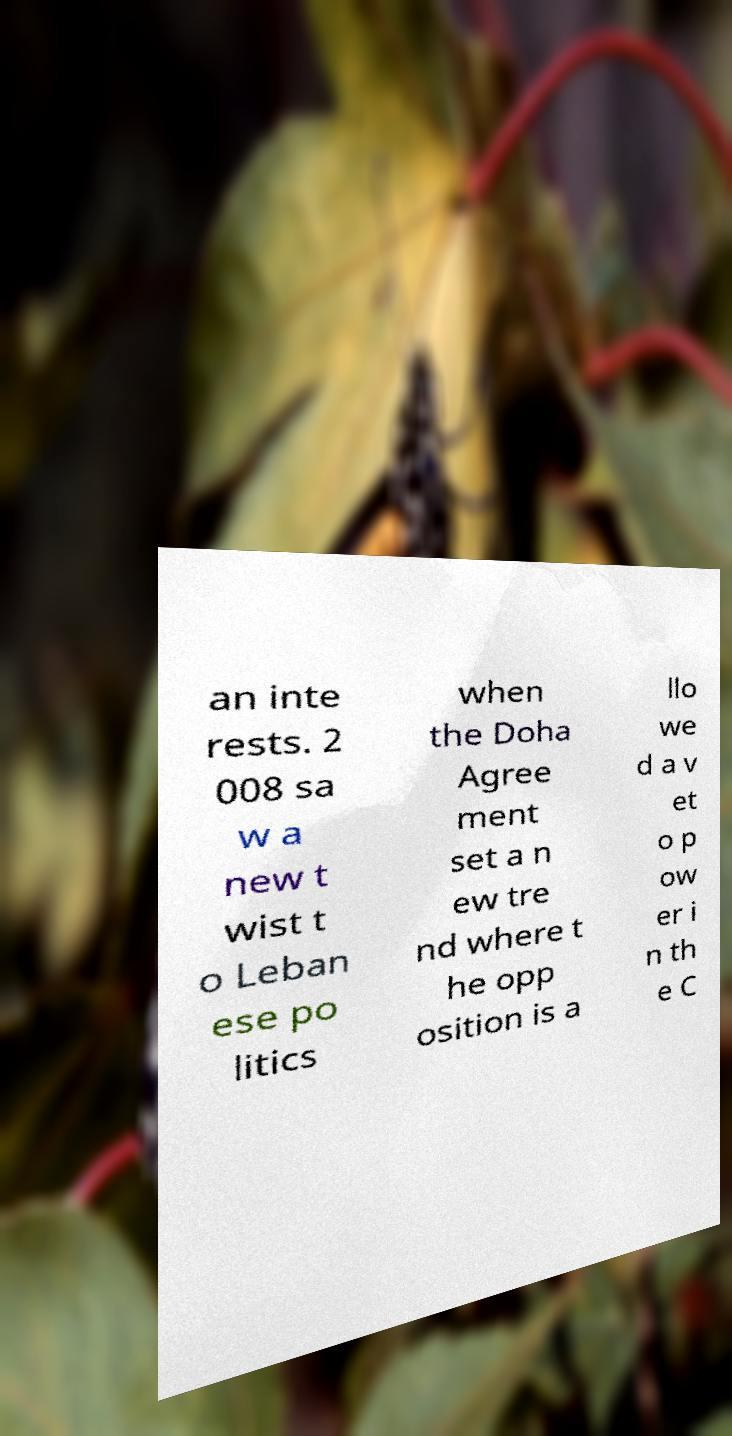Please read and relay the text visible in this image. What does it say? an inte rests. 2 008 sa w a new t wist t o Leban ese po litics when the Doha Agree ment set a n ew tre nd where t he opp osition is a llo we d a v et o p ow er i n th e C 